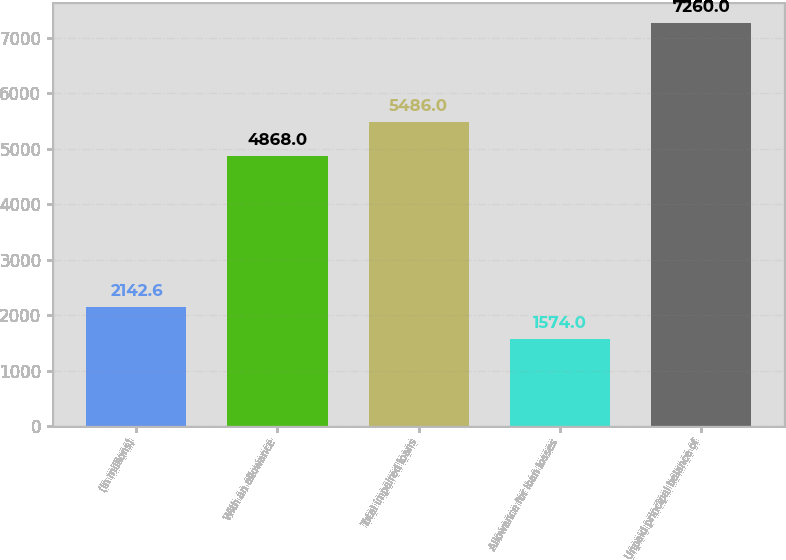Convert chart. <chart><loc_0><loc_0><loc_500><loc_500><bar_chart><fcel>(in millions)<fcel>With an allowance<fcel>Total impaired loans<fcel>Allowance for loan losses<fcel>Unpaid principal balance of<nl><fcel>2142.6<fcel>4868<fcel>5486<fcel>1574<fcel>7260<nl></chart> 